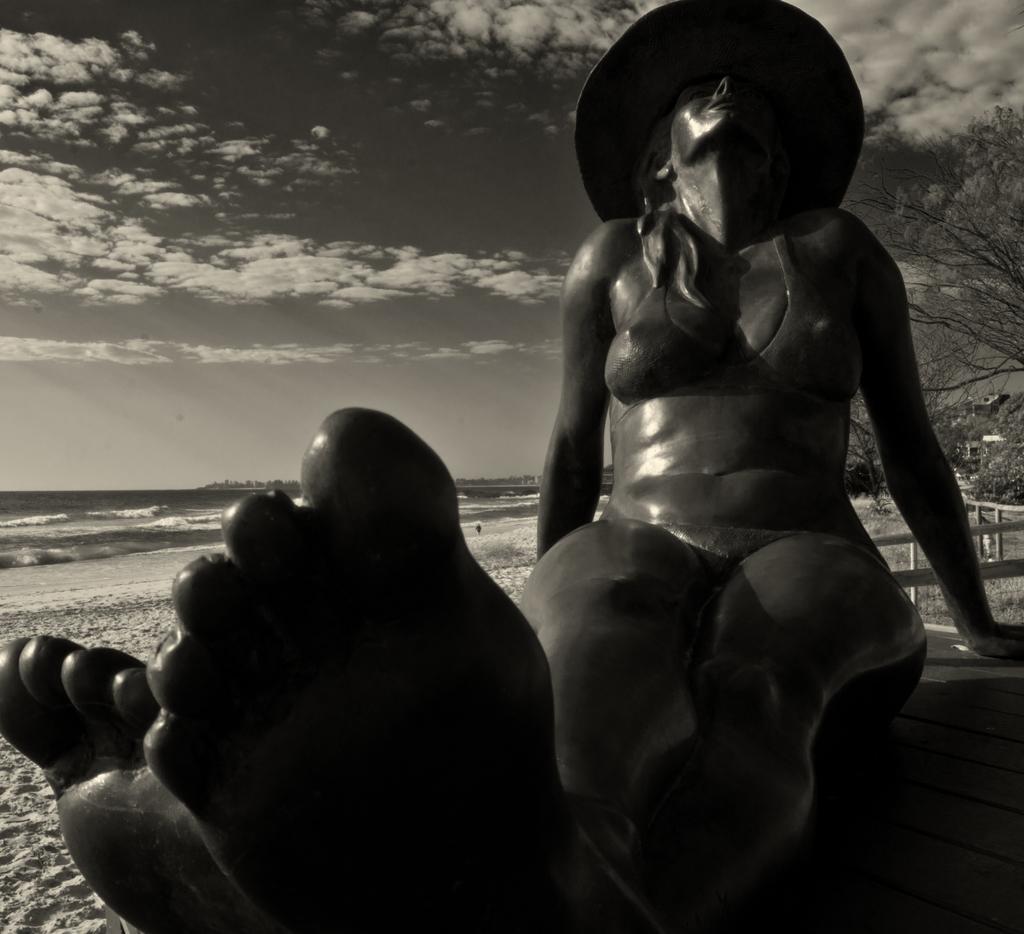Could you give a brief overview of what you see in this image? This is a black and white image. Here I can see a woman wearing a cap on the head, sitting and looking at the upwards. It seems to be a statue. In the background there is a beach. On the right side there are trees. At the top of the image I can see the sky and clouds. 